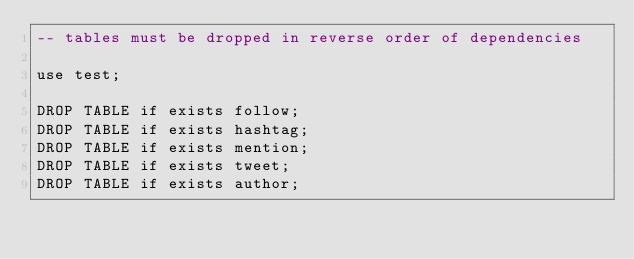Convert code to text. <code><loc_0><loc_0><loc_500><loc_500><_SQL_>-- tables must be dropped in reverse order of dependencies

use test;

DROP TABLE if exists follow;
DROP TABLE if exists hashtag;
DROP TABLE if exists mention;
DROP TABLE if exists tweet;
DROP TABLE if exists author;

 </code> 